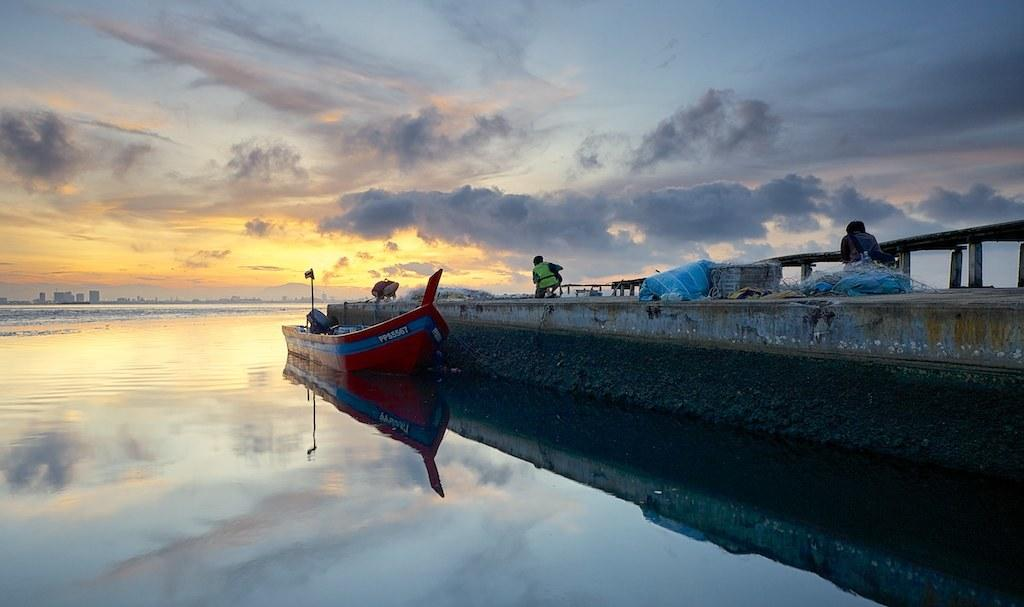What is the main feature of the image? There is water in the image. What is on the water in the image? There is a boat on the water. What is located on the right side of the image? There is a wall on the right side of the image. Can you describe the people visible in the image? There are people visible in the image. What can be seen in the background of the image? There is a bridge, buildings, and the sky visible in the background of the image. What type of animal is being lifted by the spy in the image? There is no animal or spy present in the image. 